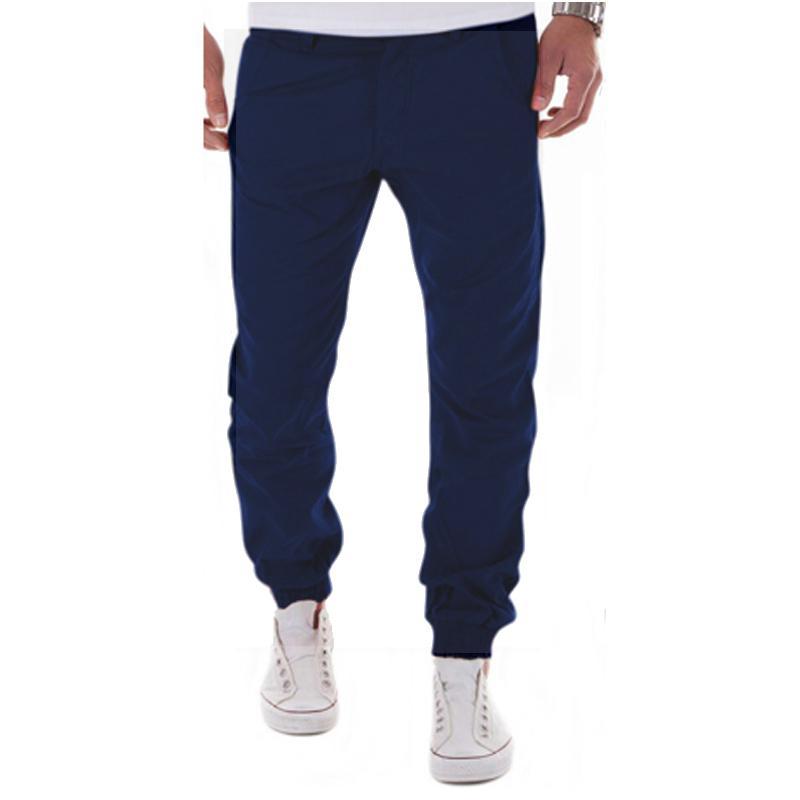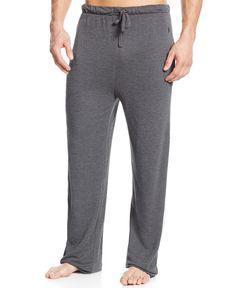The first image is the image on the left, the second image is the image on the right. Considering the images on both sides, is "One of two models shown is wearing shoes and the other is barefoot." valid? Answer yes or no. Yes. 